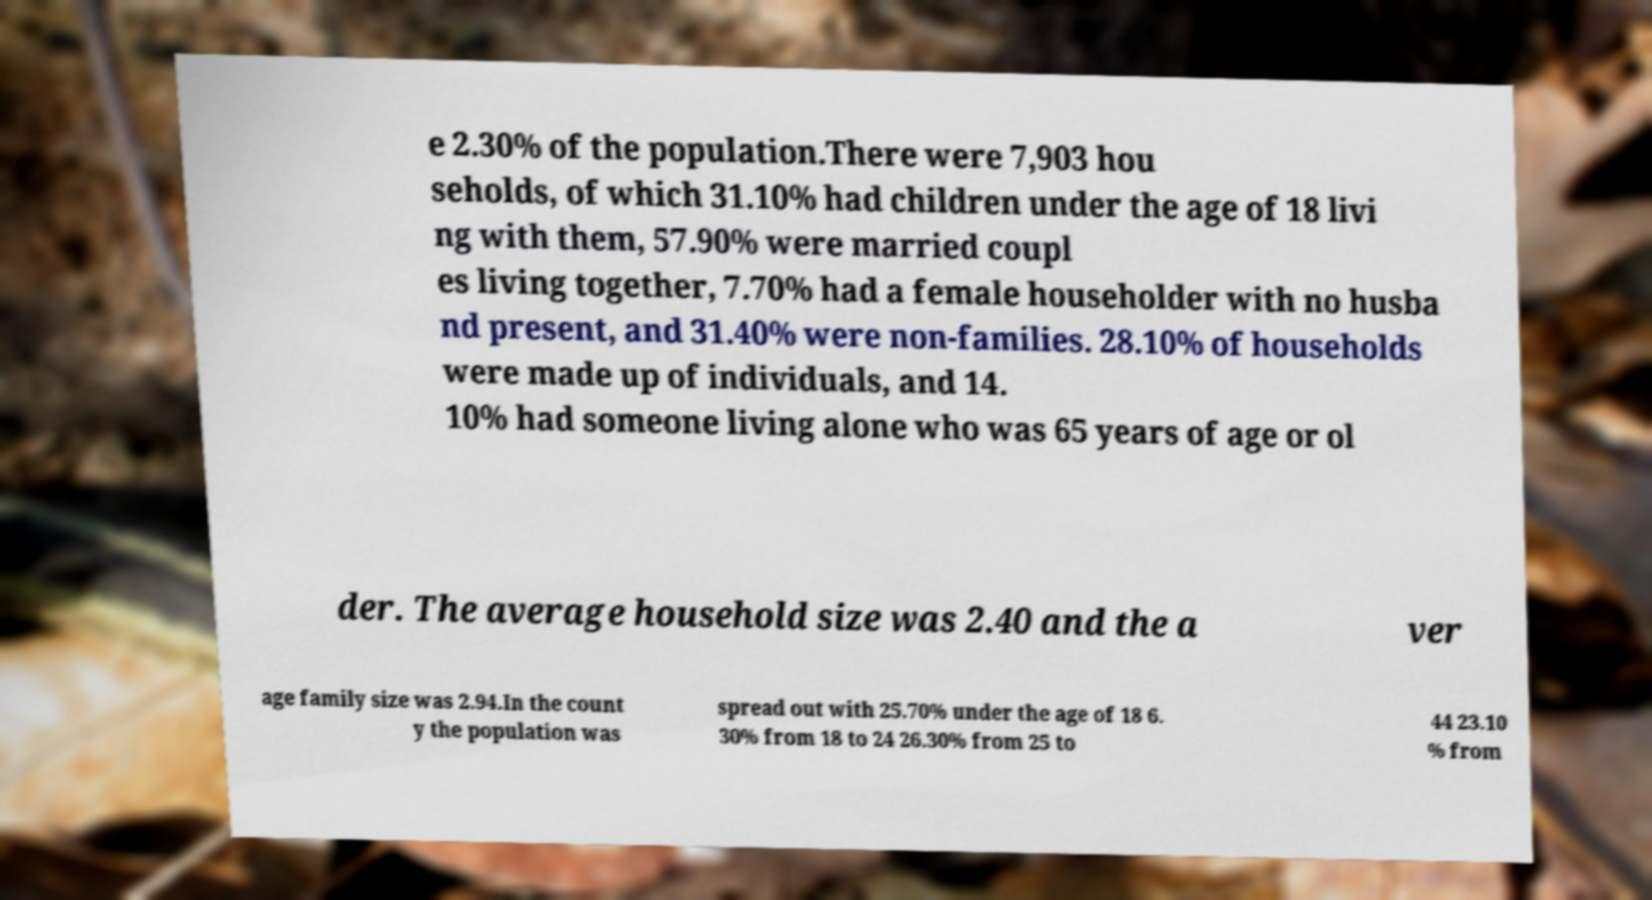There's text embedded in this image that I need extracted. Can you transcribe it verbatim? e 2.30% of the population.There were 7,903 hou seholds, of which 31.10% had children under the age of 18 livi ng with them, 57.90% were married coupl es living together, 7.70% had a female householder with no husba nd present, and 31.40% were non-families. 28.10% of households were made up of individuals, and 14. 10% had someone living alone who was 65 years of age or ol der. The average household size was 2.40 and the a ver age family size was 2.94.In the count y the population was spread out with 25.70% under the age of 18 6. 30% from 18 to 24 26.30% from 25 to 44 23.10 % from 